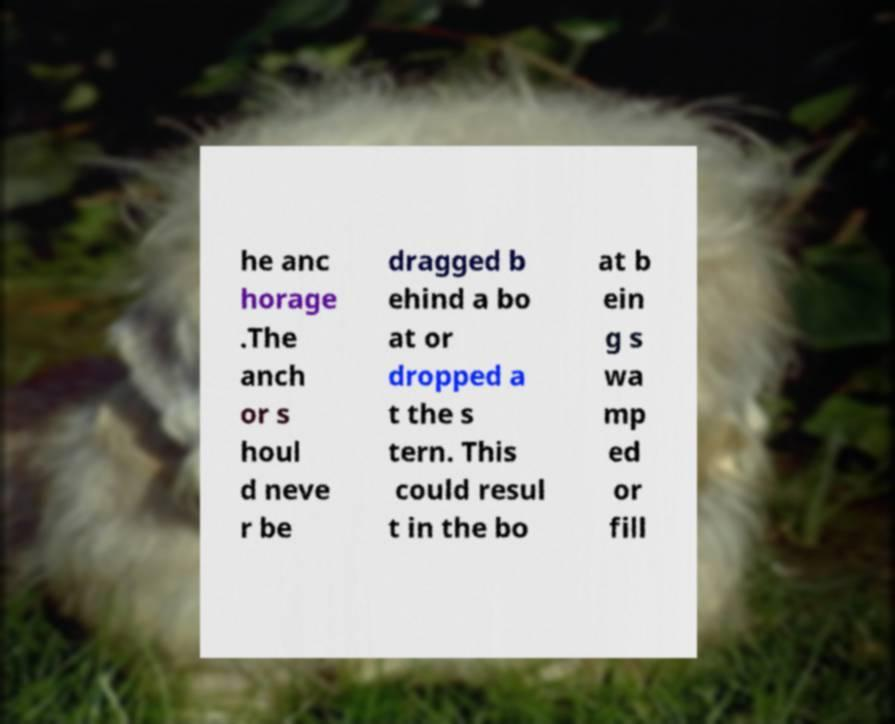Could you assist in decoding the text presented in this image and type it out clearly? he anc horage .The anch or s houl d neve r be dragged b ehind a bo at or dropped a t the s tern. This could resul t in the bo at b ein g s wa mp ed or fill 